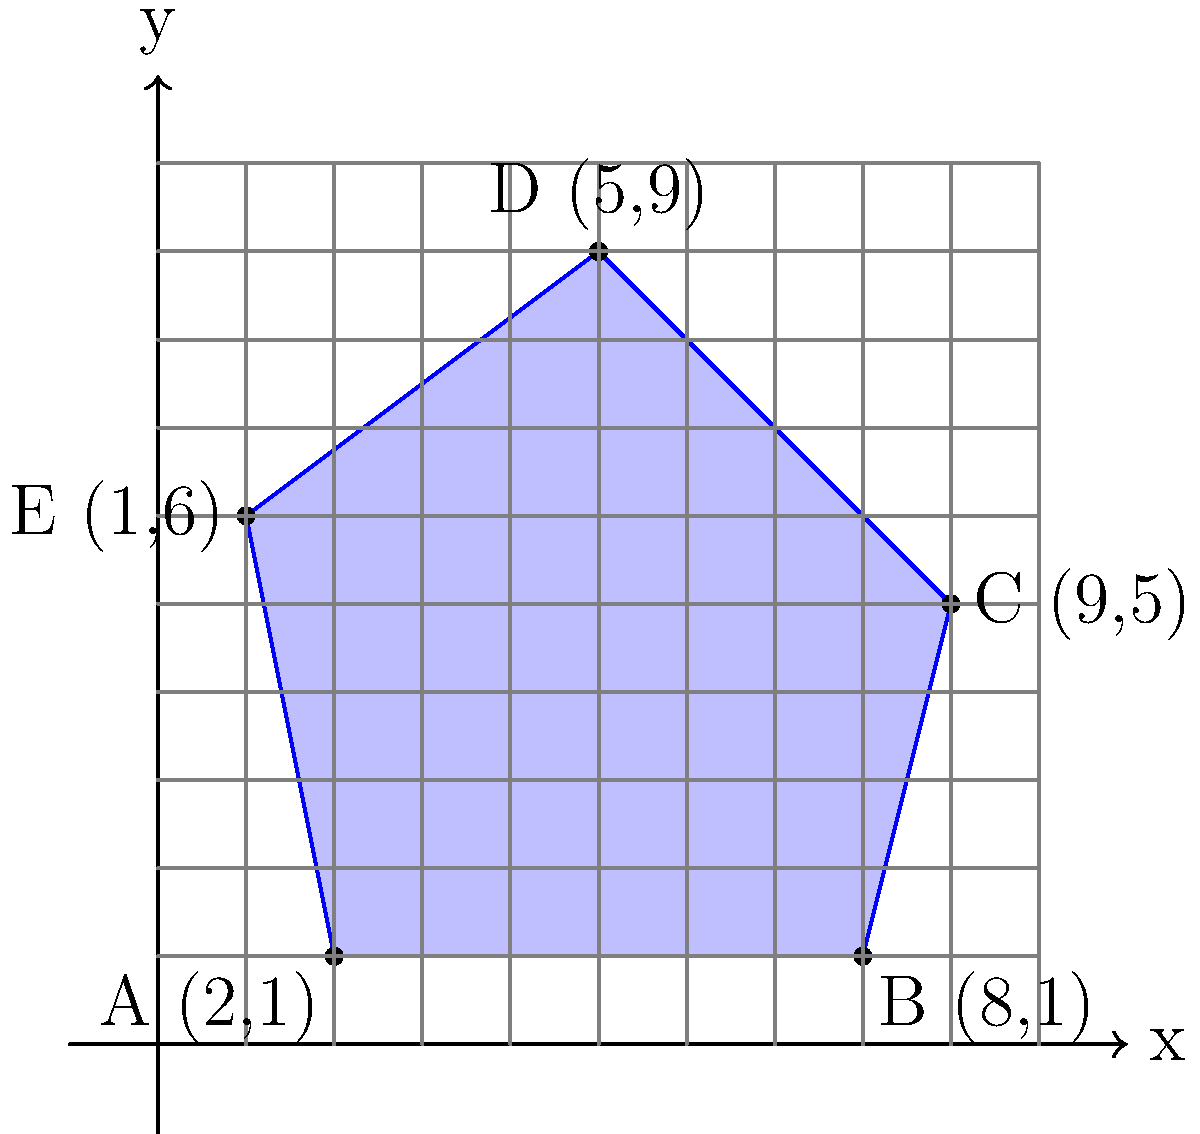As you research your ancestral property for your historical fiction novel, you discover an old map showing the boundaries of the land. The property is represented by a polygon on a coordinate system, with vertices at A(2,1), B(8,1), C(9,5), D(5,9), and E(1,6). Calculate the area of this ancestral property in square units. To calculate the area of the polygon representing the ancestral property, we can use the Shoelace formula (also known as the surveyor's formula). This method is particularly useful for irregular polygons given by coordinate points.

The Shoelace formula is:

$$ \text{Area} = \frac{1}{2}|\sum_{i=1}^{n-1} (x_i y_{i+1} + x_n y_1) - \sum_{i=1}^{n-1} (y_i x_{i+1} + y_n x_1)| $$

Where $(x_i, y_i)$ are the coordinates of the $i$-th vertex.

Let's apply this formula to our polygon:

1) First, let's list our points in order:
   A(2,1), B(8,1), C(9,5), D(5,9), E(1,6)

2) Now, let's calculate the first sum:
   $$(2 \cdot 1) + (8 \cdot 5) + (9 \cdot 9) + (5 \cdot 6) + (1 \cdot 1) = 2 + 40 + 81 + 30 + 1 = 154$$

3) Calculate the second sum:
   $$(1 \cdot 8) + (1 \cdot 9) + (5 \cdot 5) + (9 \cdot 1) + (6 \cdot 2) = 8 + 9 + 25 + 9 + 12 = 63$$

4) Subtract the second sum from the first:
   $$154 - 63 = 91$$

5) Take the absolute value (in this case, it's already positive) and divide by 2:
   $$\frac{91}{2} = 45.5$$

Therefore, the area of the ancestral property is 45.5 square units.
Answer: 45.5 square units 